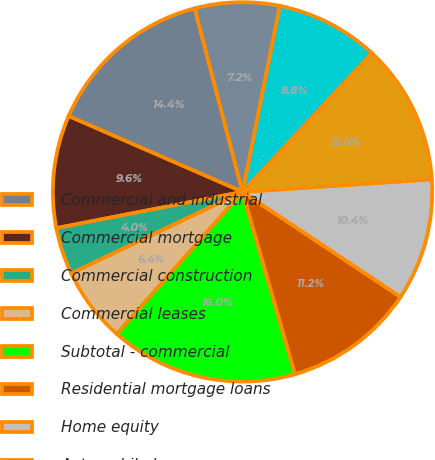Convert chart. <chart><loc_0><loc_0><loc_500><loc_500><pie_chart><fcel>Commercial and industrial<fcel>Commercial mortgage<fcel>Commercial construction<fcel>Commercial leases<fcel>Subtotal - commercial<fcel>Residential mortgage loans<fcel>Home equity<fcel>Automobile loans<fcel>Credit card<fcel>Other consumer loans/leases<nl><fcel>14.4%<fcel>9.6%<fcel>4.01%<fcel>6.4%<fcel>15.99%<fcel>11.2%<fcel>10.4%<fcel>12.0%<fcel>8.8%<fcel>7.2%<nl></chart> 